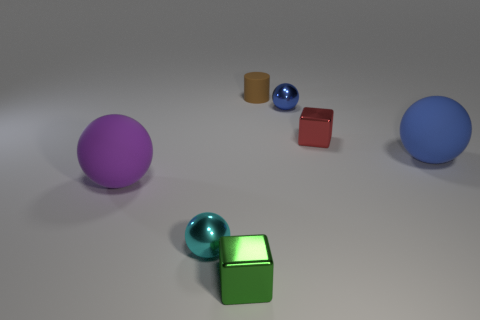Subtract all purple balls. How many balls are left? 3 Add 2 small purple shiny blocks. How many objects exist? 9 Subtract all green blocks. How many blocks are left? 1 Subtract all balls. How many objects are left? 3 Subtract 0 brown cubes. How many objects are left? 7 Subtract 1 cylinders. How many cylinders are left? 0 Subtract all red cylinders. Subtract all brown cubes. How many cylinders are left? 1 Subtract all green cylinders. How many blue blocks are left? 0 Subtract all blue spheres. Subtract all rubber objects. How many objects are left? 2 Add 3 small cylinders. How many small cylinders are left? 4 